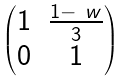Convert formula to latex. <formula><loc_0><loc_0><loc_500><loc_500>\begin{pmatrix} 1 & \frac { 1 - \ w } { 3 } \\ 0 & 1 \end{pmatrix}</formula> 